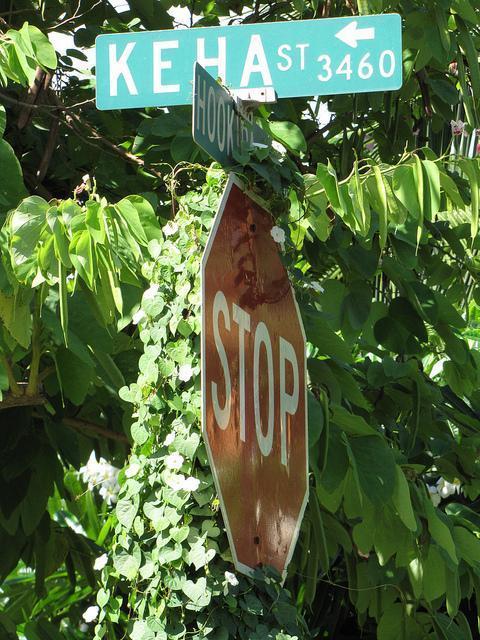How many stop signs can you see?
Give a very brief answer. 1. 